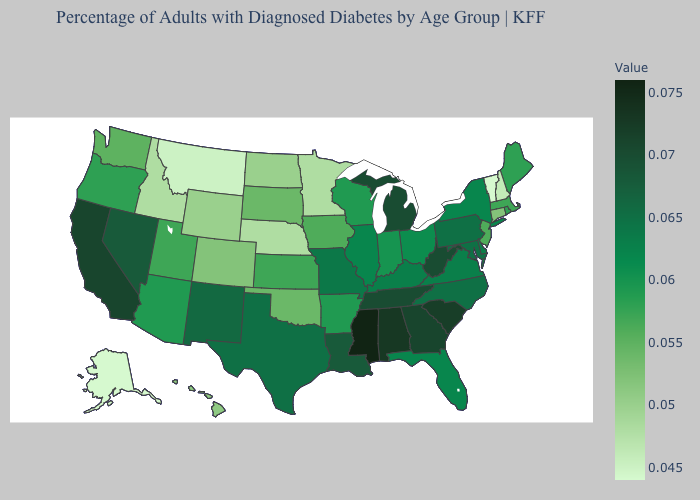Does the map have missing data?
Give a very brief answer. No. Does Texas have a lower value than South Carolina?
Quick response, please. Yes. Among the states that border North Dakota , does Minnesota have the highest value?
Concise answer only. No. Does the map have missing data?
Be succinct. No. Does Alaska have the lowest value in the West?
Answer briefly. Yes. Does Alaska have the lowest value in the USA?
Answer briefly. Yes. Which states have the highest value in the USA?
Be succinct. Mississippi. 